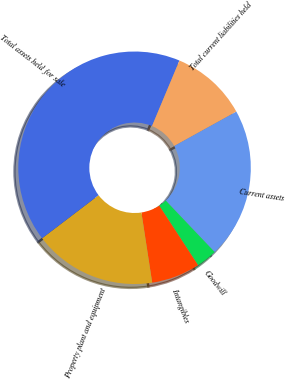<chart> <loc_0><loc_0><loc_500><loc_500><pie_chart><fcel>Current assets<fcel>Goodwill<fcel>Intangibles<fcel>Property plant and equipment<fcel>Total assets held for sale<fcel>Total current liabilities held<nl><fcel>20.94%<fcel>2.9%<fcel>6.77%<fcel>17.06%<fcel>41.67%<fcel>10.65%<nl></chart> 